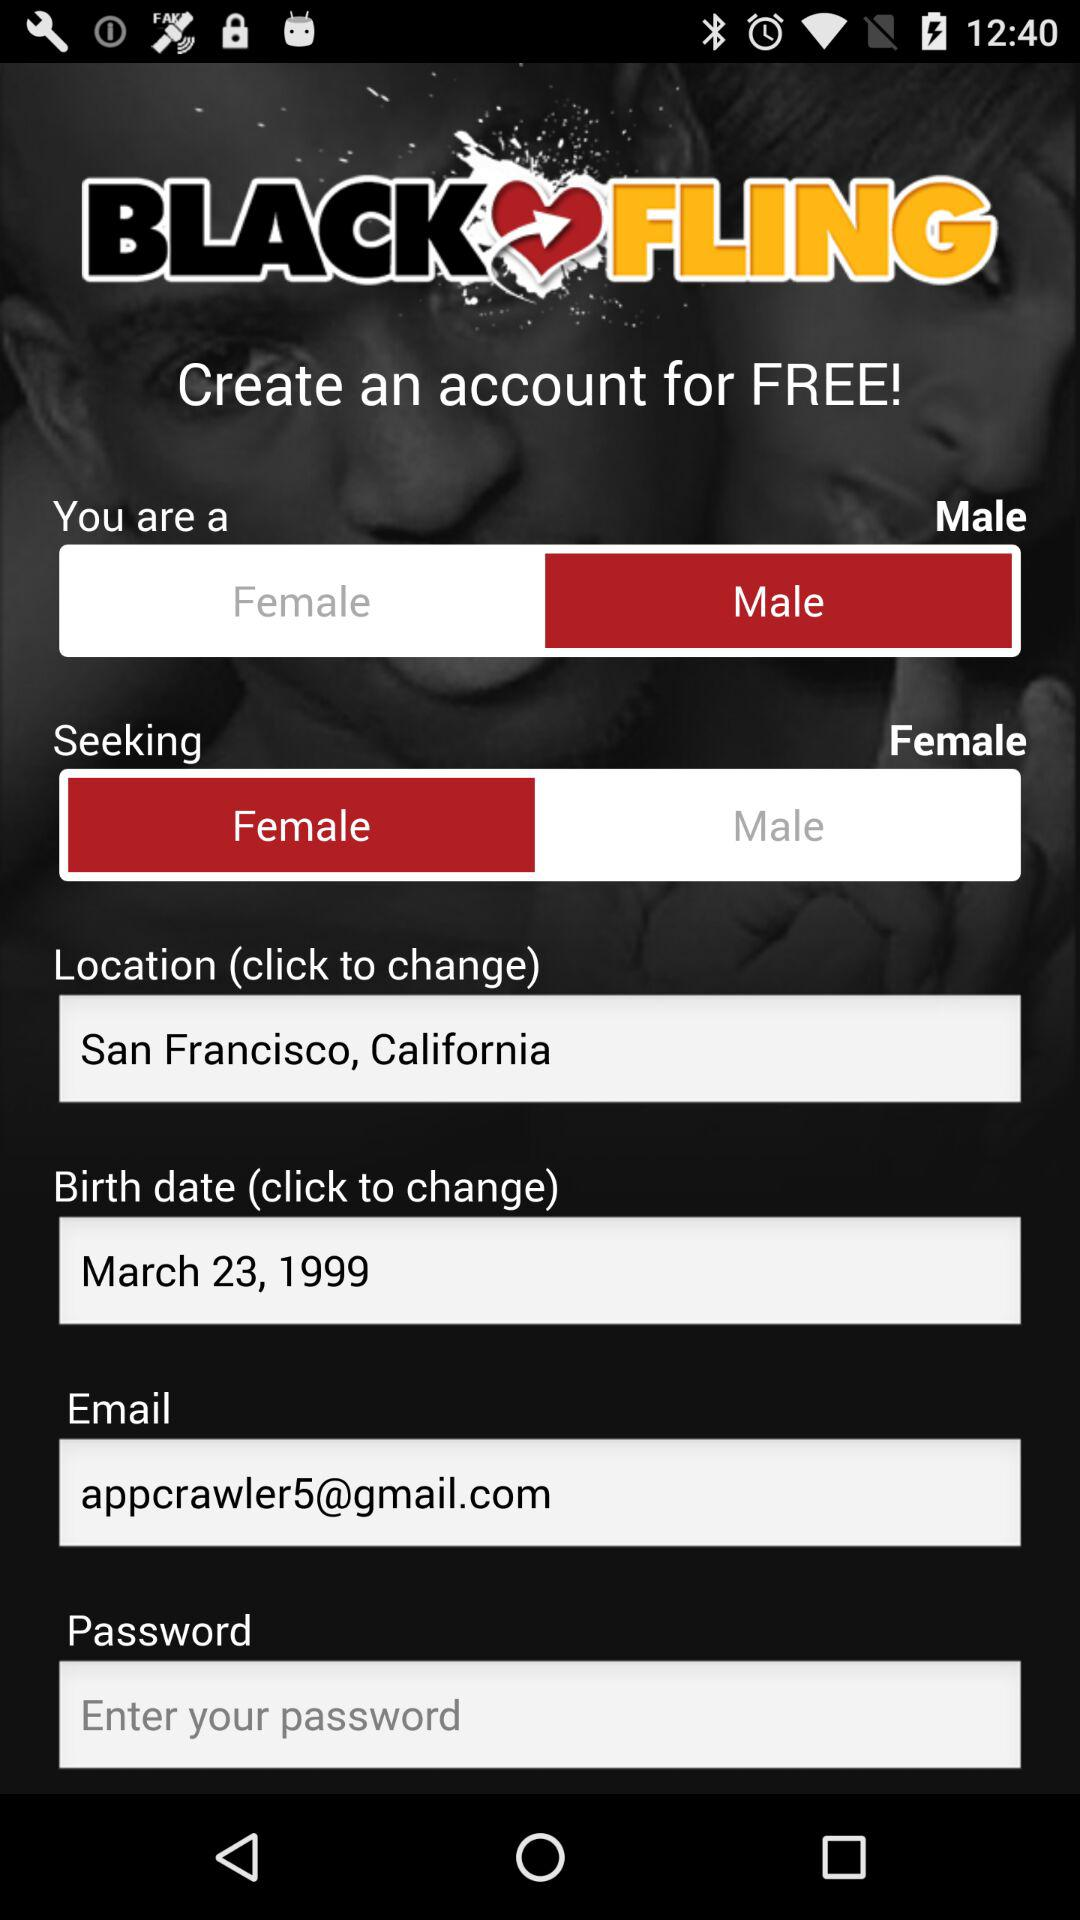What is the birth date? The birth date is March 23, 1999. 